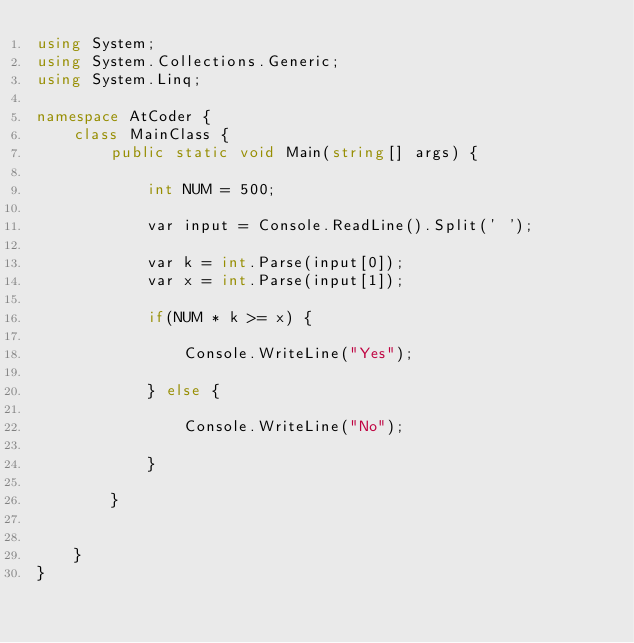<code> <loc_0><loc_0><loc_500><loc_500><_C#_>using System;
using System.Collections.Generic;
using System.Linq;

namespace AtCoder {
    class MainClass {
        public static void Main(string[] args) {

            int NUM = 500;

            var input = Console.ReadLine().Split(' ');

            var k = int.Parse(input[0]);
            var x = int.Parse(input[1]);

            if(NUM * k >= x) {

                Console.WriteLine("Yes");

            } else {

                Console.WriteLine("No");

            }

        }

        
    }
}</code> 